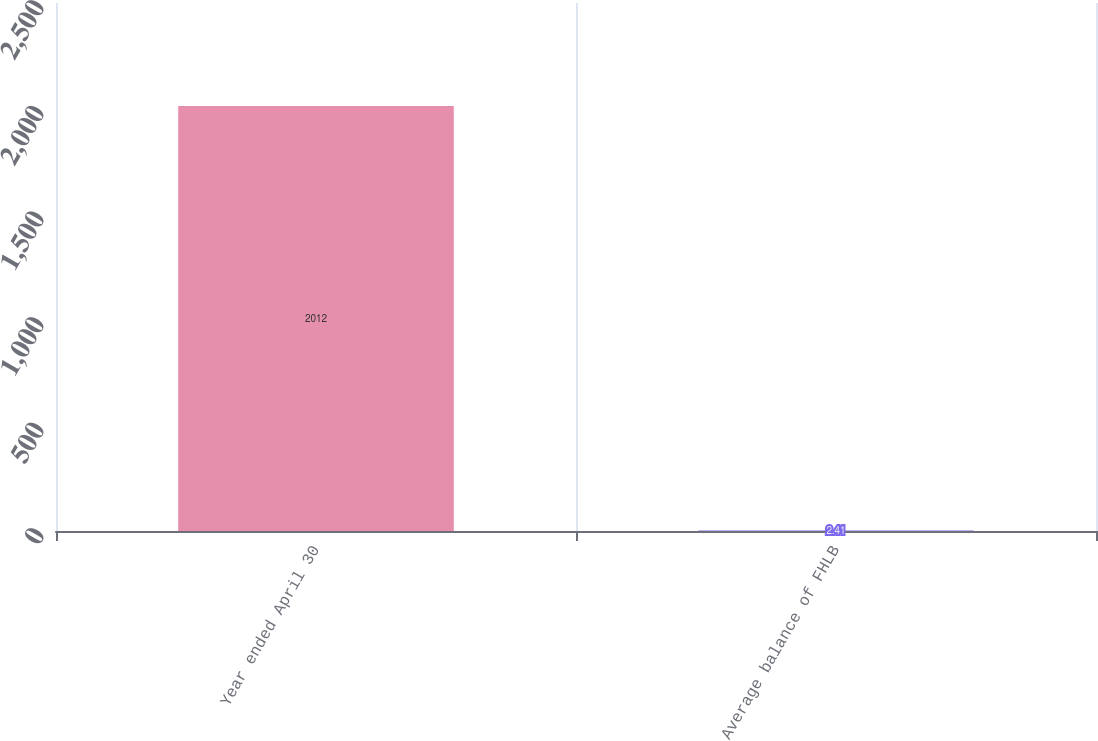Convert chart to OTSL. <chart><loc_0><loc_0><loc_500><loc_500><bar_chart><fcel>Year ended April 30<fcel>Average balance of FHLB<nl><fcel>2012<fcel>2.41<nl></chart> 